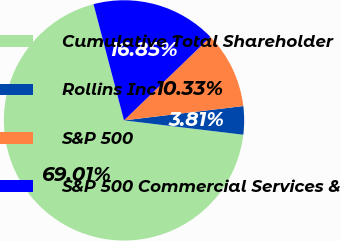<chart> <loc_0><loc_0><loc_500><loc_500><pie_chart><fcel>Cumulative Total Shareholder<fcel>Rollins Inc<fcel>S&P 500<fcel>S&P 500 Commercial Services &<nl><fcel>69.01%<fcel>3.81%<fcel>10.33%<fcel>16.85%<nl></chart> 